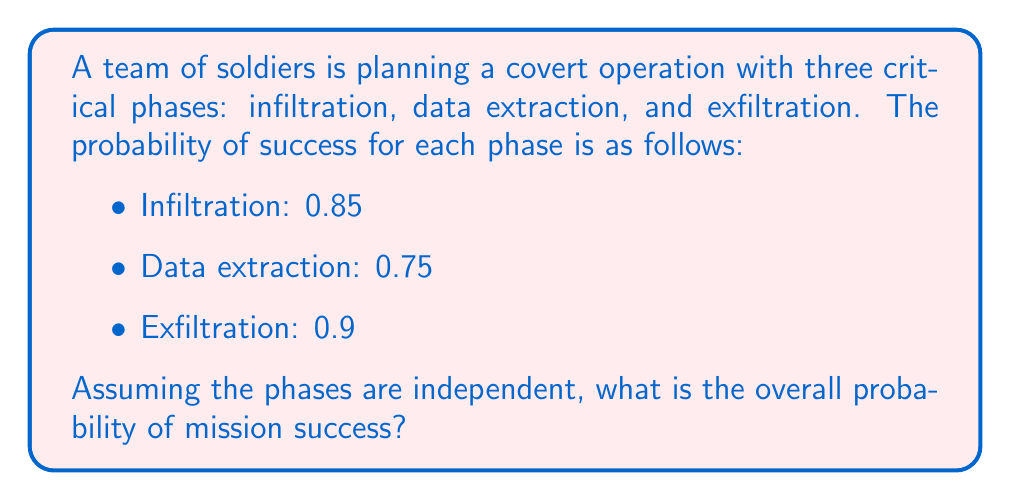Solve this math problem. To solve this problem, we'll follow these steps:

1) In probability theory, when we have independent events that must all occur for an overall success, we multiply the individual probabilities.

2) Let's define our events:
   A = Successful infiltration
   B = Successful data extraction
   C = Successful exfiltration

3) We're looking for P(A ∩ B ∩ C), which, due to independence, equals P(A) × P(B) × P(C)

4) We're given:
   P(A) = 0.85
   P(B) = 0.75
   P(C) = 0.90

5) Now, let's calculate:

   $$P(\text{Mission Success}) = P(A) \times P(B) \times P(C)$$
   $$= 0.85 \times 0.75 \times 0.90$$
   $$= 0.57375$$

6) Converting to a percentage:
   0.57375 × 100% = 57.375%

Therefore, the overall probability of mission success is approximately 57.38%.
Answer: 0.57375 or 57.38% 